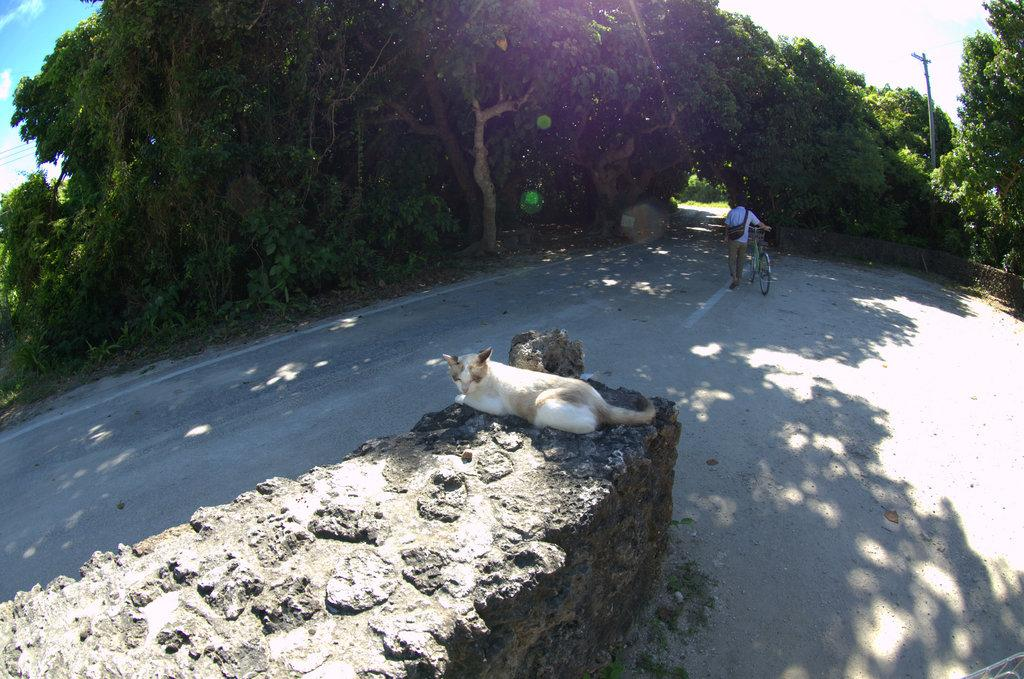What animal can be seen in the image? There is a cat laying on a wall in the image. What is the person in the image doing? The person is holding a bicycle and walking on a road in the image. What type of vegetation is visible in the top of the image? There are trees and plants visible in the top of the image. What other objects can be seen in the top of the image? There is a pole and the sky visible in the top of the image. What type of competition is taking place in the bedroom in the image? There is no bedroom or competition present in the image. 